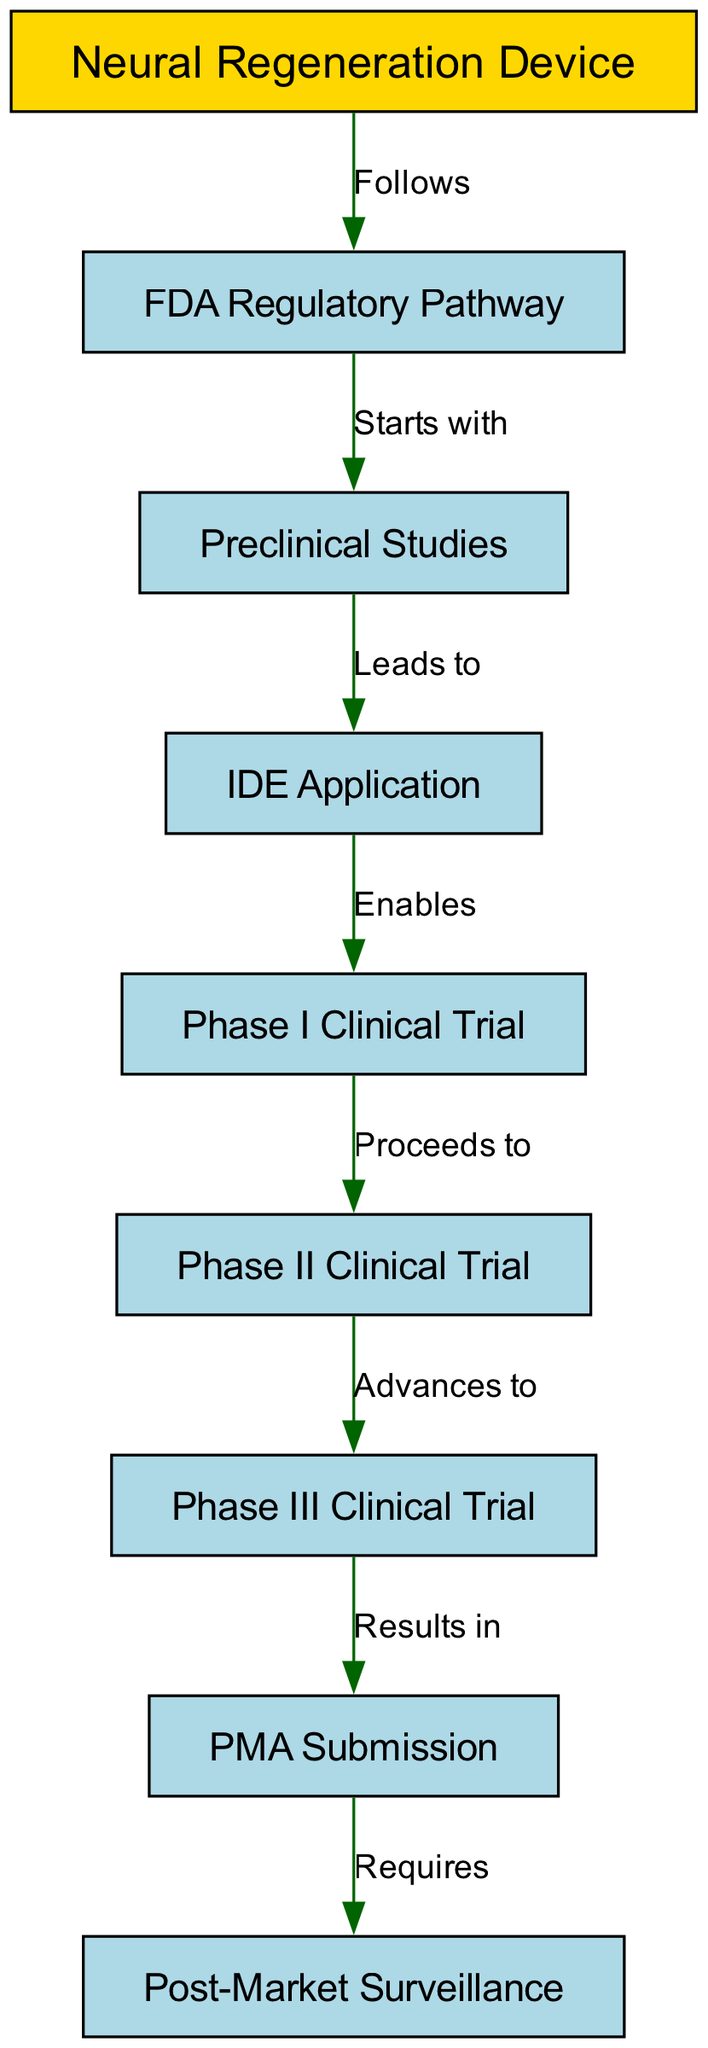What is the starting point in the regulatory pathway? The diagram indicates that the regulatory pathway begins with "Preclinical Studies," as it is the first node connected to the FDA Regulatory Pathway.
Answer: Preclinical Studies How many phases are in the clinical trials? Upon examining the diagram, there are three clinical trial phases depicted: Phase I, Phase II, and Phase III.
Answer: Three What does an IDE application enable? The flow from the IDE Application to Phase I Clinical Trial shows that the application enables the commencement of clinical trials.
Answer: Phase I Clinical Trial What comes after Phase II Clinical Trial? According to the diagram, after Phase II Clinical Trial, the process advances to Phase III Clinical Trial as indicated by the connecting edge.
Answer: Phase III Clinical Trial What is required after a PMA submission? The final node linked to PMA Submission indicates that it requires Post-Market Surveillance, establishing the necessity for ongoing evaluations after the device is marketed.
Answer: Post-Market Surveillance Which node leads to the IDE application? In tracing the connections, "Preclinical Studies" leads directly to the IDE Application, as represented by the directed edge in the diagram.
Answer: Preclinical Studies What follows the Post-Market Surveillance? The diagram shows that Post-Market Surveillance is the final step in the process and does not lead to any further steps. Therefore, there is nothing that follows it.
Answer: Nothing What is the relationship between the FDA Regulatory Pathway and the Neural Regeneration Device? The edge labeled "Follows" indicates that the FDA Regulatory Pathway follows from the Neural Regeneration Device, establishing a sequential connection in the diagram.
Answer: Follows 